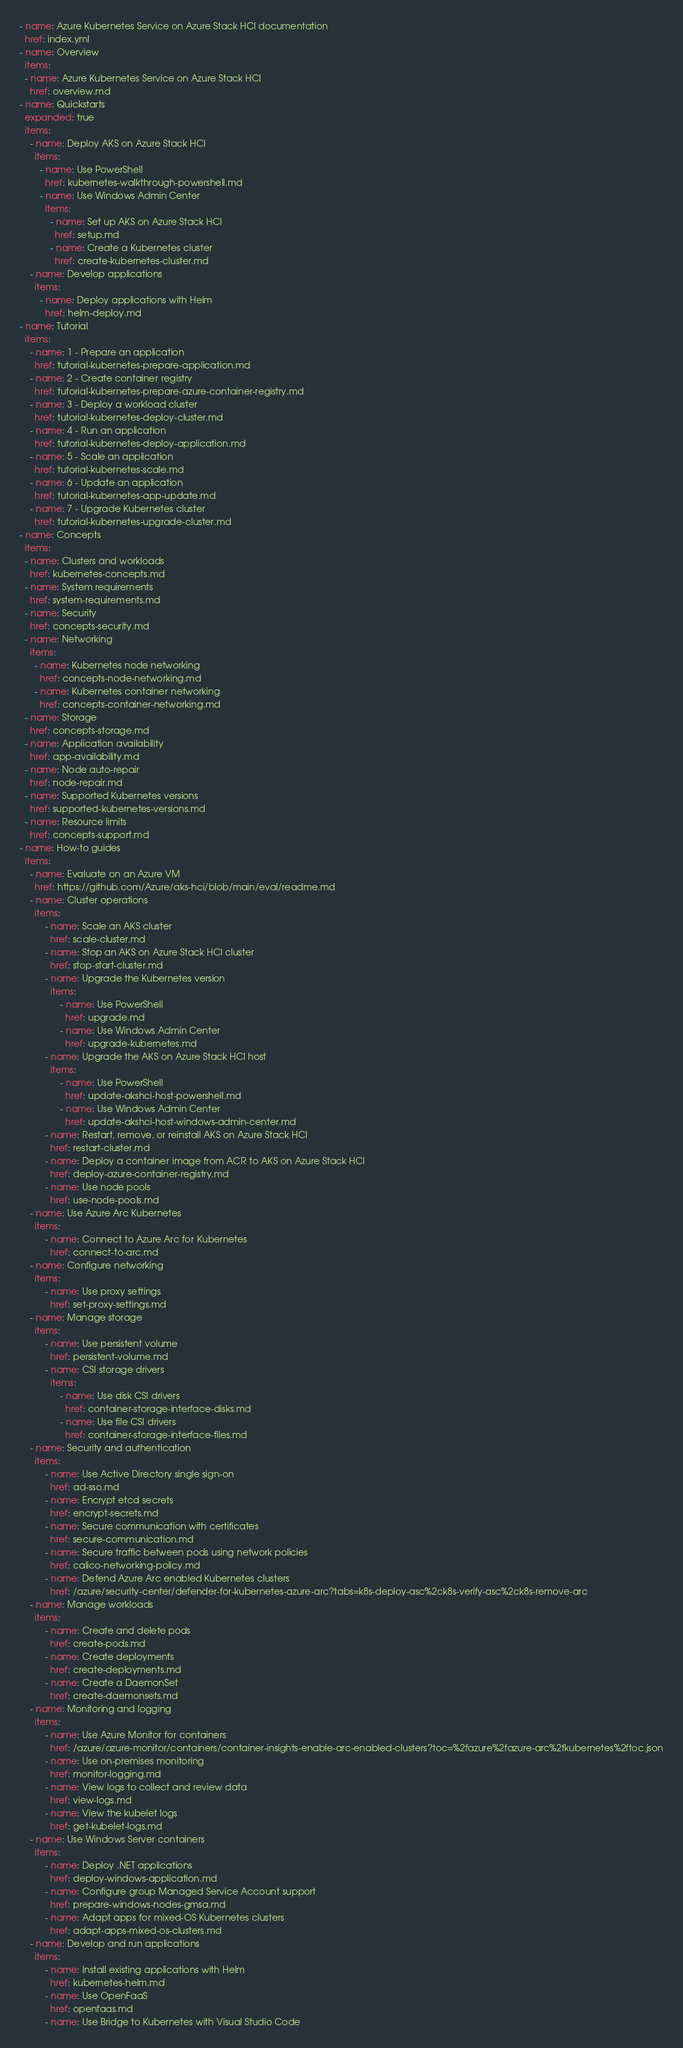<code> <loc_0><loc_0><loc_500><loc_500><_YAML_>- name: Azure Kubernetes Service on Azure Stack HCI documentation
  href: index.yml
- name: Overview
  items:
  - name: Azure Kubernetes Service on Azure Stack HCI
    href: overview.md
- name: Quickstarts
  expanded: true
  items:
    - name: Deploy AKS on Azure Stack HCI
      items:
        - name: Use PowerShell
          href: kubernetes-walkthrough-powershell.md
        - name: Use Windows Admin Center
          items:
            - name: Set up AKS on Azure Stack HCI
              href: setup.md
            - name: Create a Kubernetes cluster
              href: create-kubernetes-cluster.md
    - name: Develop applications
      items:
        - name: Deploy applications with Helm
          href: helm-deploy.md
- name: Tutorial
  items:
    - name: 1 - Prepare an application
      href: tutorial-kubernetes-prepare-application.md
    - name: 2 - Create container registry
      href: tutorial-kubernetes-prepare-azure-container-registry.md
    - name: 3 - Deploy a workload cluster
      href: tutorial-kubernetes-deploy-cluster.md
    - name: 4 - Run an application
      href: tutorial-kubernetes-deploy-application.md
    - name: 5 - Scale an application
      href: tutorial-kubernetes-scale.md
    - name: 6 - Update an application
      href: tutorial-kubernetes-app-update.md
    - name: 7 - Upgrade Kubernetes cluster
      href: tutorial-kubernetes-upgrade-cluster.md
- name: Concepts
  items:
  - name: Clusters and workloads
    href: kubernetes-concepts.md
  - name: System requirements
    href: system-requirements.md
  - name: Security
    href: concepts-security.md
  - name: Networking
    items:
      - name: Kubernetes node networking
        href: concepts-node-networking.md
      - name: Kubernetes container networking
        href: concepts-container-networking.md
  - name: Storage
    href: concepts-storage.md
  - name: Application availability
    href: app-availability.md
  - name: Node auto-repair
    href: node-repair.md
  - name: Supported Kubernetes versions
    href: supported-kubernetes-versions.md
  - name: Resource limits
    href: concepts-support.md
- name: How-to guides
  items: 
    - name: Evaluate on an Azure VM
      href: https://github.com/Azure/aks-hci/blob/main/eval/readme.md
    - name: Cluster operations
      items:    
          - name: Scale an AKS cluster
            href: scale-cluster.md
          - name: Stop an AKS on Azure Stack HCI cluster
            href: stop-start-cluster.md
          - name: Upgrade the Kubernetes version
            items:
                - name: Use PowerShell
                  href: upgrade.md
                - name: Use Windows Admin Center
                  href: upgrade-kubernetes.md
          - name: Upgrade the AKS on Azure Stack HCI host
            items:
                - name: Use PowerShell
                  href: update-akshci-host-powershell.md
                - name: Use Windows Admin Center
                  href: update-akshci-host-windows-admin-center.md
          - name: Restart, remove, or reinstall AKS on Azure Stack HCI
            href: restart-cluster.md
          - name: Deploy a container image from ACR to AKS on Azure Stack HCI
            href: deploy-azure-container-registry.md
          - name: Use node pools
            href: use-node-pools.md
    - name: Use Azure Arc Kubernetes
      items:
          - name: Connect to Azure Arc for Kubernetes
            href: connect-to-arc.md
    - name: Configure networking
      items:
          - name: Use proxy settings
            href: set-proxy-settings.md
    - name: Manage storage
      items:
          - name: Use persistent volume
            href: persistent-volume.md
          - name: CSI storage drivers
            items: 
                - name: Use disk CSI drivers
                  href: container-storage-interface-disks.md
                - name: Use file CSI drivers
                  href: container-storage-interface-files.md
    - name: Security and authentication
      items:
          - name: Use Active Directory single sign-on
            href: ad-sso.md
          - name: Encrypt etcd secrets
            href: encrypt-secrets.md
          - name: Secure communication with certificates
            href: secure-communication.md
          - name: Secure traffic between pods using network policies
            href: calico-networking-policy.md
          - name: Defend Azure Arc enabled Kubernetes clusters
            href: /azure/security-center/defender-for-kubernetes-azure-arc?tabs=k8s-deploy-asc%2ck8s-verify-asc%2ck8s-remove-arc
    - name: Manage workloads
      items:
          - name: Create and delete pods
            href: create-pods.md
          - name: Create deployments
            href: create-deployments.md
          - name: Create a DaemonSet
            href: create-daemonsets.md
    - name: Monitoring and logging
      items:    
          - name: Use Azure Monitor for containers
            href: /azure/azure-monitor/containers/container-insights-enable-arc-enabled-clusters?toc=%2fazure%2fazure-arc%2fkubernetes%2ftoc.json
          - name: Use on-premises monitoring
            href: monitor-logging.md
          - name: View logs to collect and review data
            href: view-logs.md
          - name: View the kubelet logs
            href: get-kubelet-logs.md
    - name: Use Windows Server containers
      items:
          - name: Deploy .NET applications
            href: deploy-windows-application.md
          - name: Configure group Managed Service Account support
            href: prepare-windows-nodes-gmsa.md
          - name: Adapt apps for mixed-OS Kubernetes clusters
            href: adapt-apps-mixed-os-clusters.md
    - name: Develop and run applications
      items:
          - name: Install existing applications with Helm
            href: kubernetes-helm.md
          - name: Use OpenFaaS
            href: openfaas.md
          - name: Use Bridge to Kubernetes with Visual Studio Code</code> 